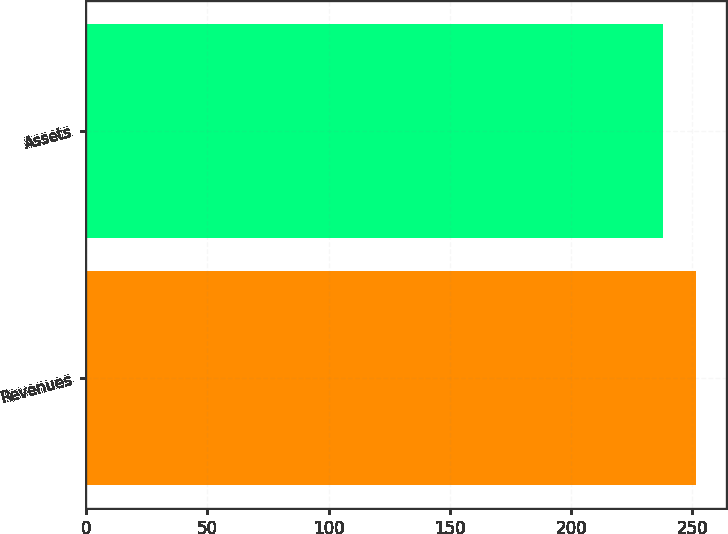Convert chart to OTSL. <chart><loc_0><loc_0><loc_500><loc_500><bar_chart><fcel>Revenues<fcel>Assets<nl><fcel>251.4<fcel>237.9<nl></chart> 